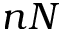Convert formula to latex. <formula><loc_0><loc_0><loc_500><loc_500>n N</formula> 